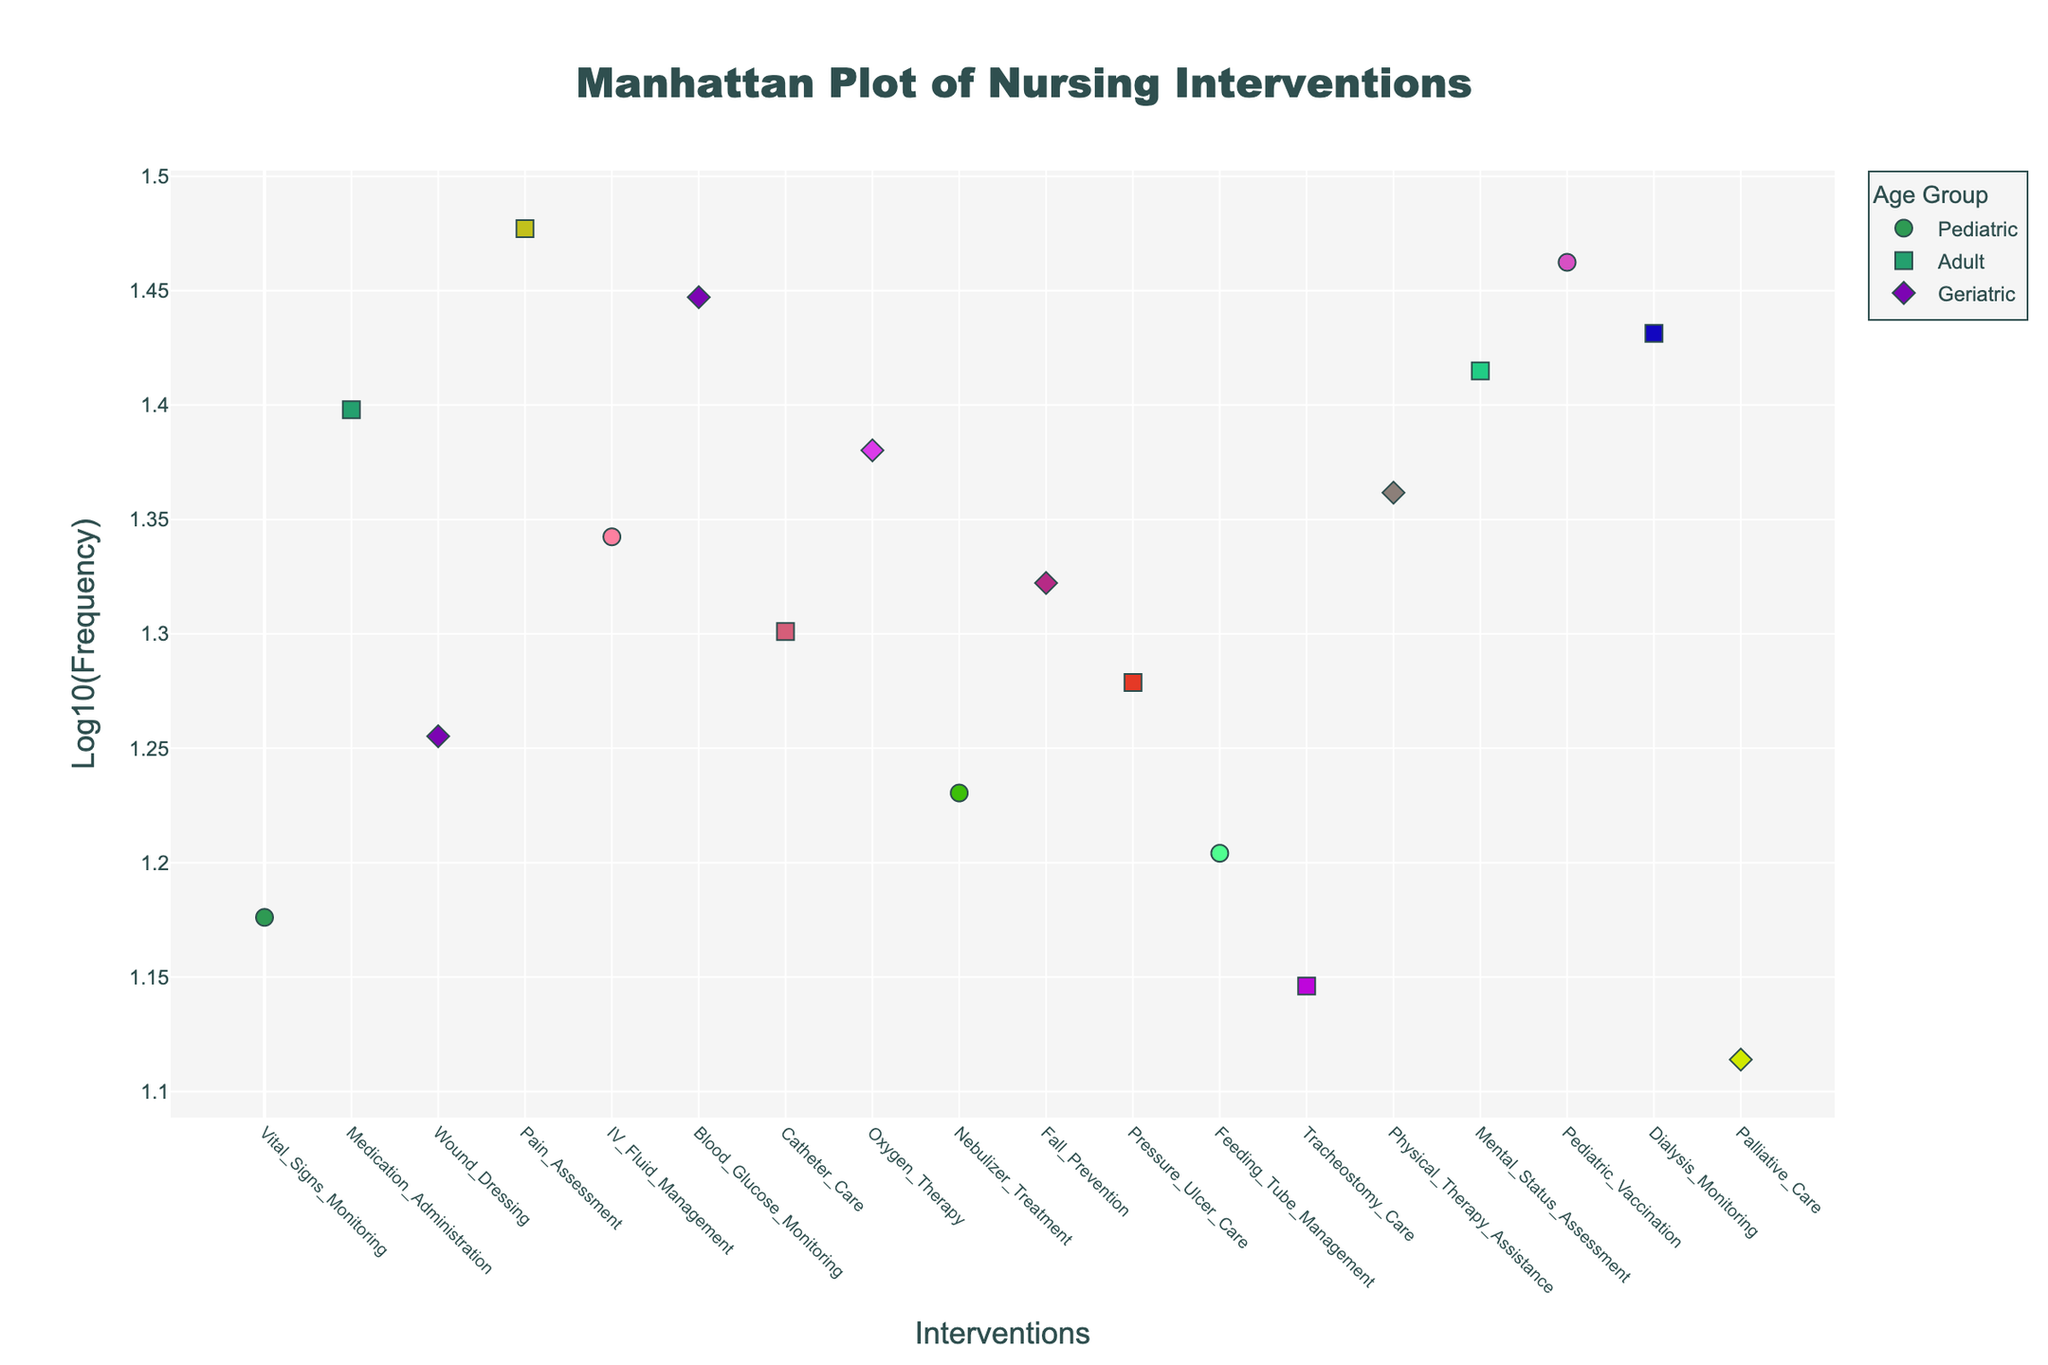How many interventions are performed on pediatric patients? Look for the interventions marked with circles on the plot. Count all the circles representing pediatric interventions.
Answer: 4 Which age group has the highest frequency intervention, and what is it? Identify the highest marker on the y-axis, which corresponds to the highest log-frequency. The Pediatric Vaccination intervention in the Pediatric age group has the highest frequency.
Answer: Pediatric, Pediatric Vaccination What is the log-frequency value of Oxygen Therapy for geriatrics with COPD? Hover over the diamond marker corresponding to Geriatrics and find the Oxygen Therapy intervention. The hover tooltip shows the log-frequency value.
Answer: Approximately 1.38 Which intervention has the lowest frequency, and for which age group and condition is it? Identify the lowest marker on the y-axis. The Palliative Care intervention for Geriatric patients with Terminal Cancer has the lowest frequency.
Answer: Palliative Care, Geriatric, Terminal Cancer How do the frequencies of interventions for adults compare, such as Pain Assessment and Tracheostomy Care? Compare the markers for Pain Assessment and Tracheostomy Care in the Adult age group (square markers). Pain Assessment has a higher log-frequency than Tracheostomy Care.
Answer: Pain Assessment has higher frequency than Tracheostomy Care What is the total frequency of nursing interventions for pediatric patients? Sum the frequencies of interventions performed on pediatric patients: 15 (Asthma) + 22 (Dehydration) + 17 (Cystic Fibrosis) + 29 (Routine Checkup) = 83.
Answer: 83 Which condition has multiple interventions performed across different age groups, and what are they? Look for conditions that appear more than once across different markers. Diabetes has interventions for Geriatrics (Wound Dressing, Blood Glucose Monitoring) and no other age group has multiple interventions for this condition.
Answer: Diabetes, Geriatric Which intervention for adults has a log-frequency value closest to 1.7? Look for adult interventions (square markers) with log-frequency values around 1.7. Dialysis Monitoring has a log-frequency value of approximately 1.7.
Answer: Dialysis Monitoring Compare the interventions for geriatric patients with Osteoporosis and those in terminal cancer conditions. Which one is more frequent? Compare the diamond markers for Fall Prevention (Osteoporosis) and Palliative Care (Terminal Cancer). Fall Prevention is higher on the y-axis, indicating more frequency.
Answer: Fall Prevention (Osteoporosis) What is the log-frequency range for interventions in the Pediatric age group? Identify the minimum and maximum log-frequency values for circle markers (Pediatric). The range is from approximately 1.18 (Asthma) to approximately 1.46 (Routine Checkup).
Answer: 1.18 to 1.46 